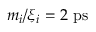<formula> <loc_0><loc_0><loc_500><loc_500>m _ { i } / \xi _ { i } = 2 \ p s</formula> 